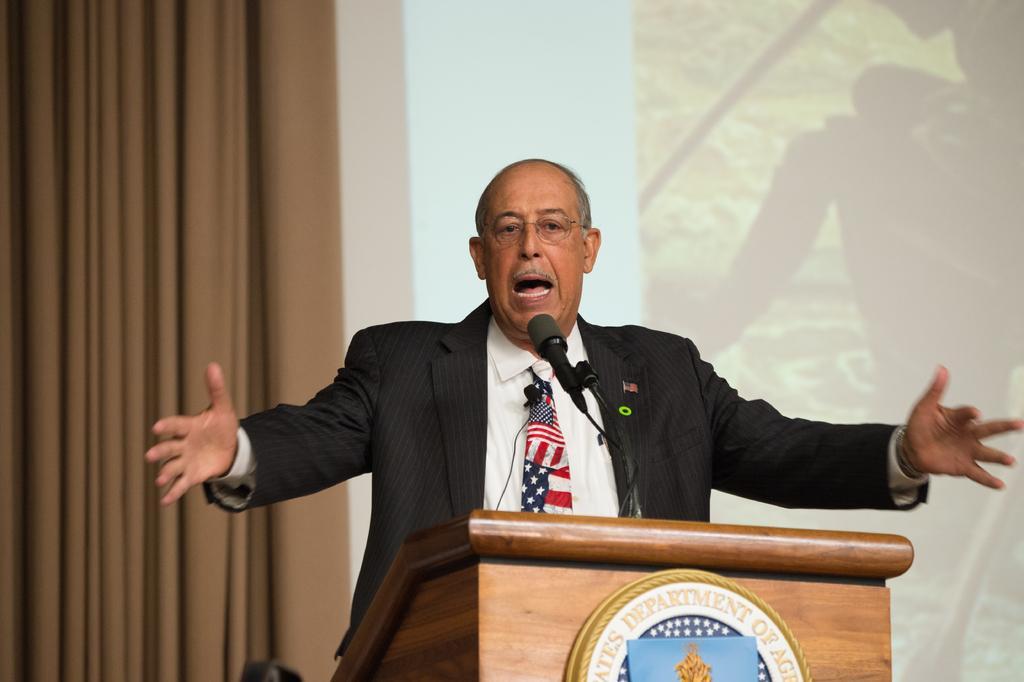In one or two sentences, can you explain what this image depicts? In this picture we can see a person wearing a spectacle and standing in front of the podium. We can see a microphone, a microphone stand and a few things on the podium. There is a curtain and a screen in the background. 